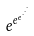<formula> <loc_0><loc_0><loc_500><loc_500>e ^ { e ^ { e ^ { \cdot ^ { \cdot ^ { \cdot } } } } }</formula> 